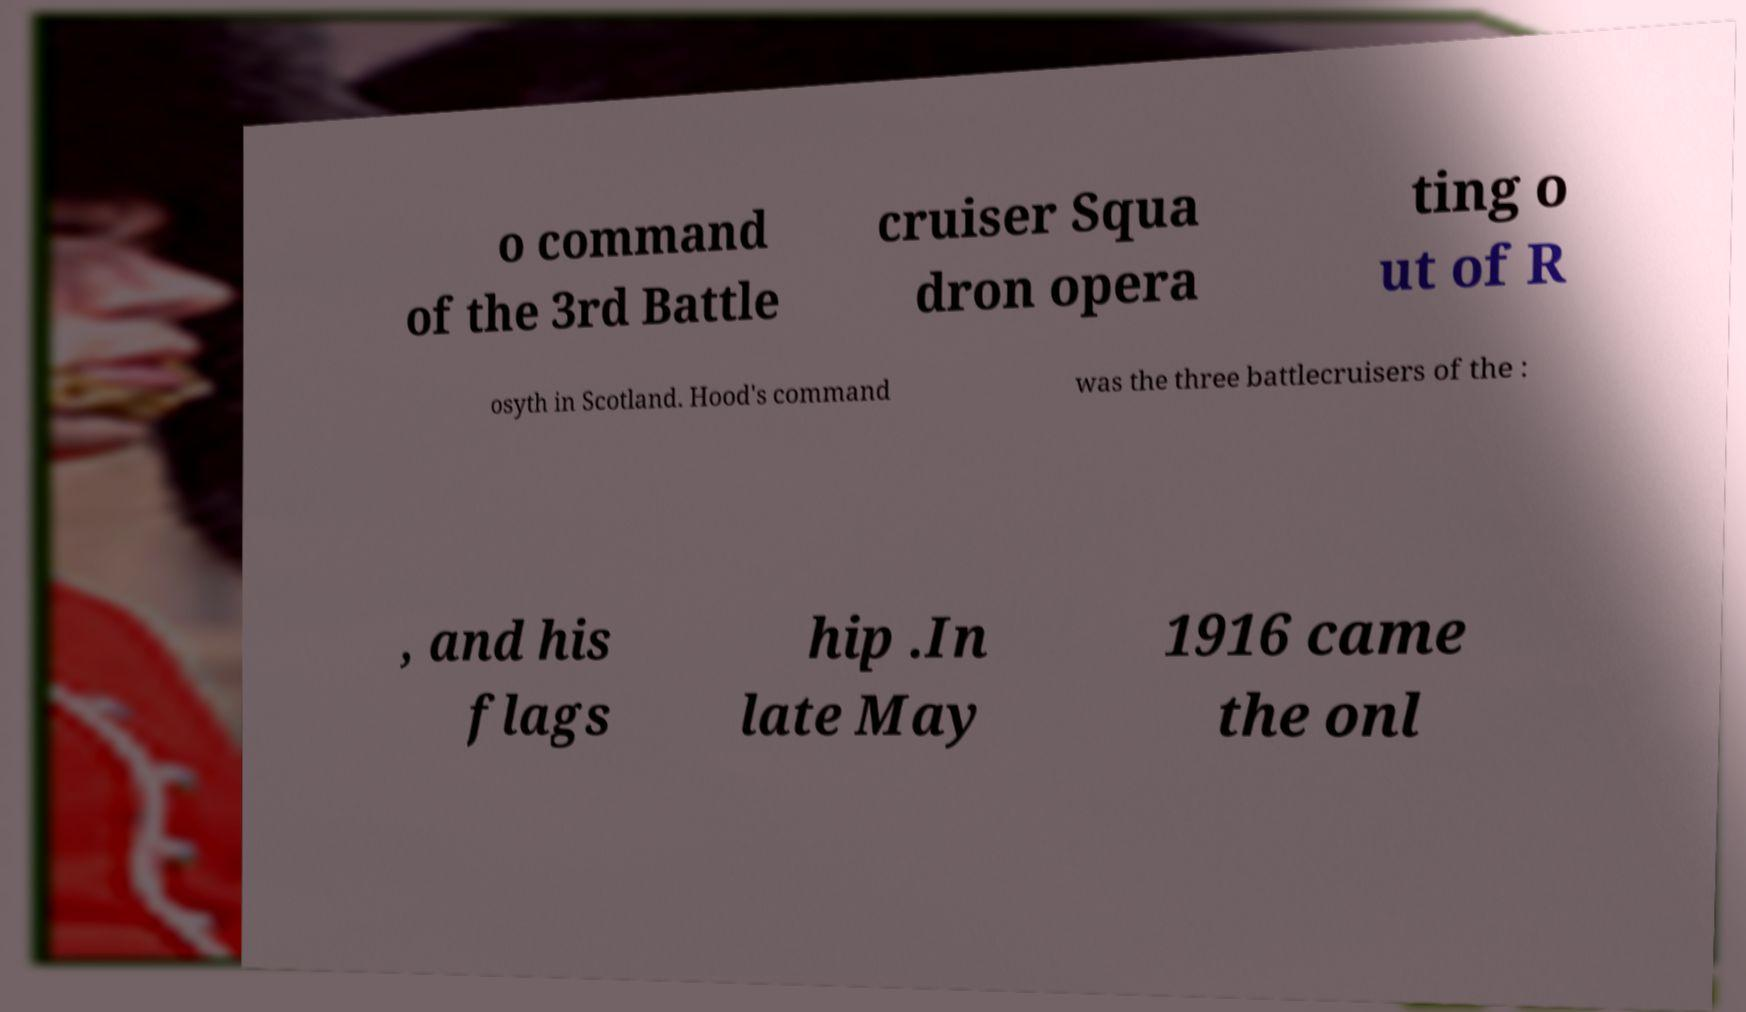There's text embedded in this image that I need extracted. Can you transcribe it verbatim? o command of the 3rd Battle cruiser Squa dron opera ting o ut of R osyth in Scotland. Hood's command was the three battlecruisers of the : , and his flags hip .In late May 1916 came the onl 